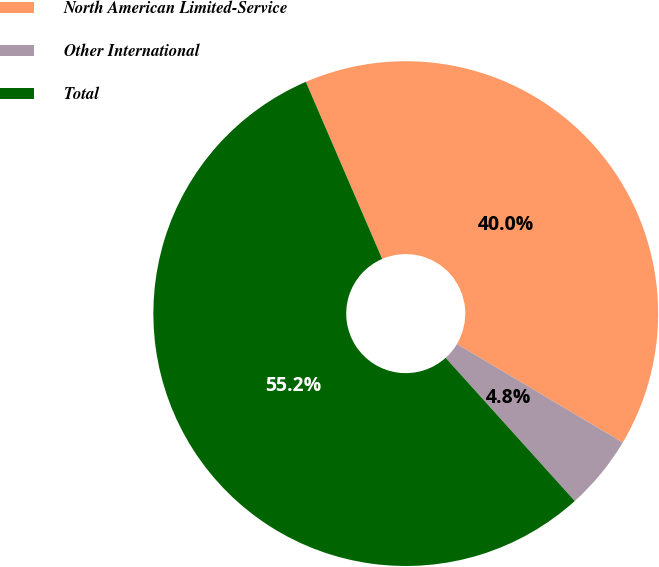Convert chart to OTSL. <chart><loc_0><loc_0><loc_500><loc_500><pie_chart><fcel>North American Limited-Service<fcel>Other International<fcel>Total<nl><fcel>40.01%<fcel>4.79%<fcel>55.2%<nl></chart> 